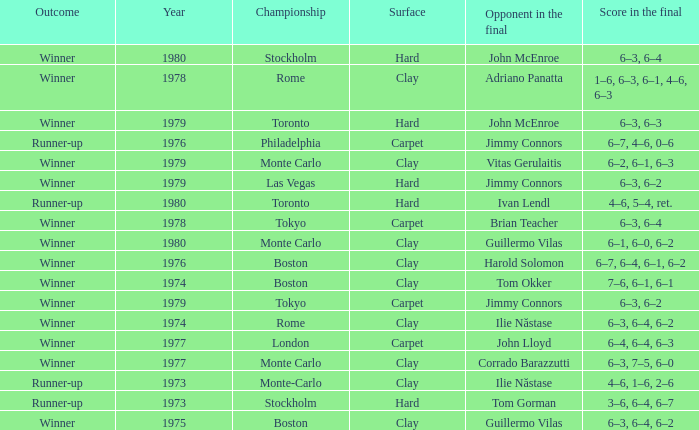Name the surface for philadelphia Carpet. 